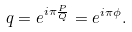Convert formula to latex. <formula><loc_0><loc_0><loc_500><loc_500>q = e ^ { i \pi \frac { P } { Q } } = e ^ { i \pi \phi } .</formula> 